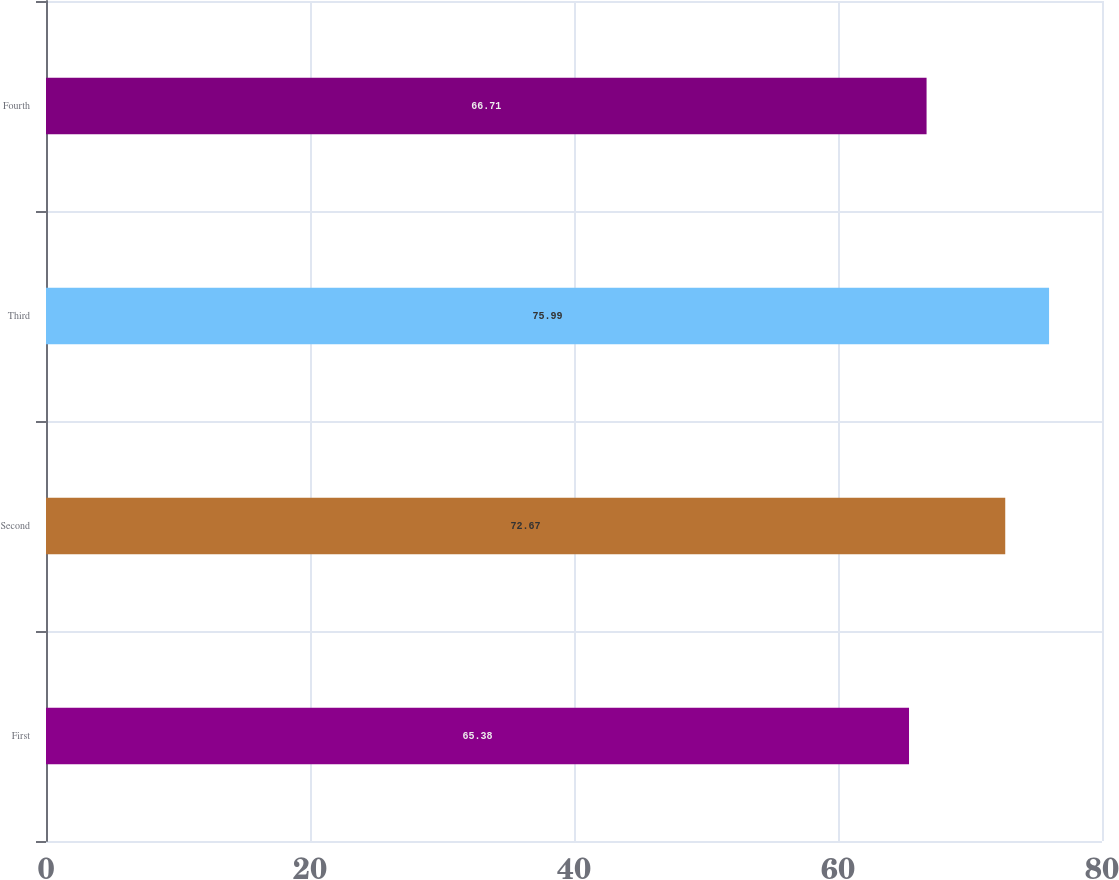<chart> <loc_0><loc_0><loc_500><loc_500><bar_chart><fcel>First<fcel>Second<fcel>Third<fcel>Fourth<nl><fcel>65.38<fcel>72.67<fcel>75.99<fcel>66.71<nl></chart> 